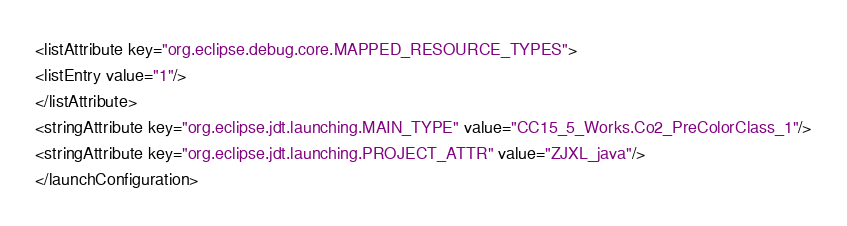Convert code to text. <code><loc_0><loc_0><loc_500><loc_500><_XML_><listAttribute key="org.eclipse.debug.core.MAPPED_RESOURCE_TYPES">
<listEntry value="1"/>
</listAttribute>
<stringAttribute key="org.eclipse.jdt.launching.MAIN_TYPE" value="CC15_5_Works.Co2_PreColorClass_1"/>
<stringAttribute key="org.eclipse.jdt.launching.PROJECT_ATTR" value="ZJXL_java"/>
</launchConfiguration>
</code> 